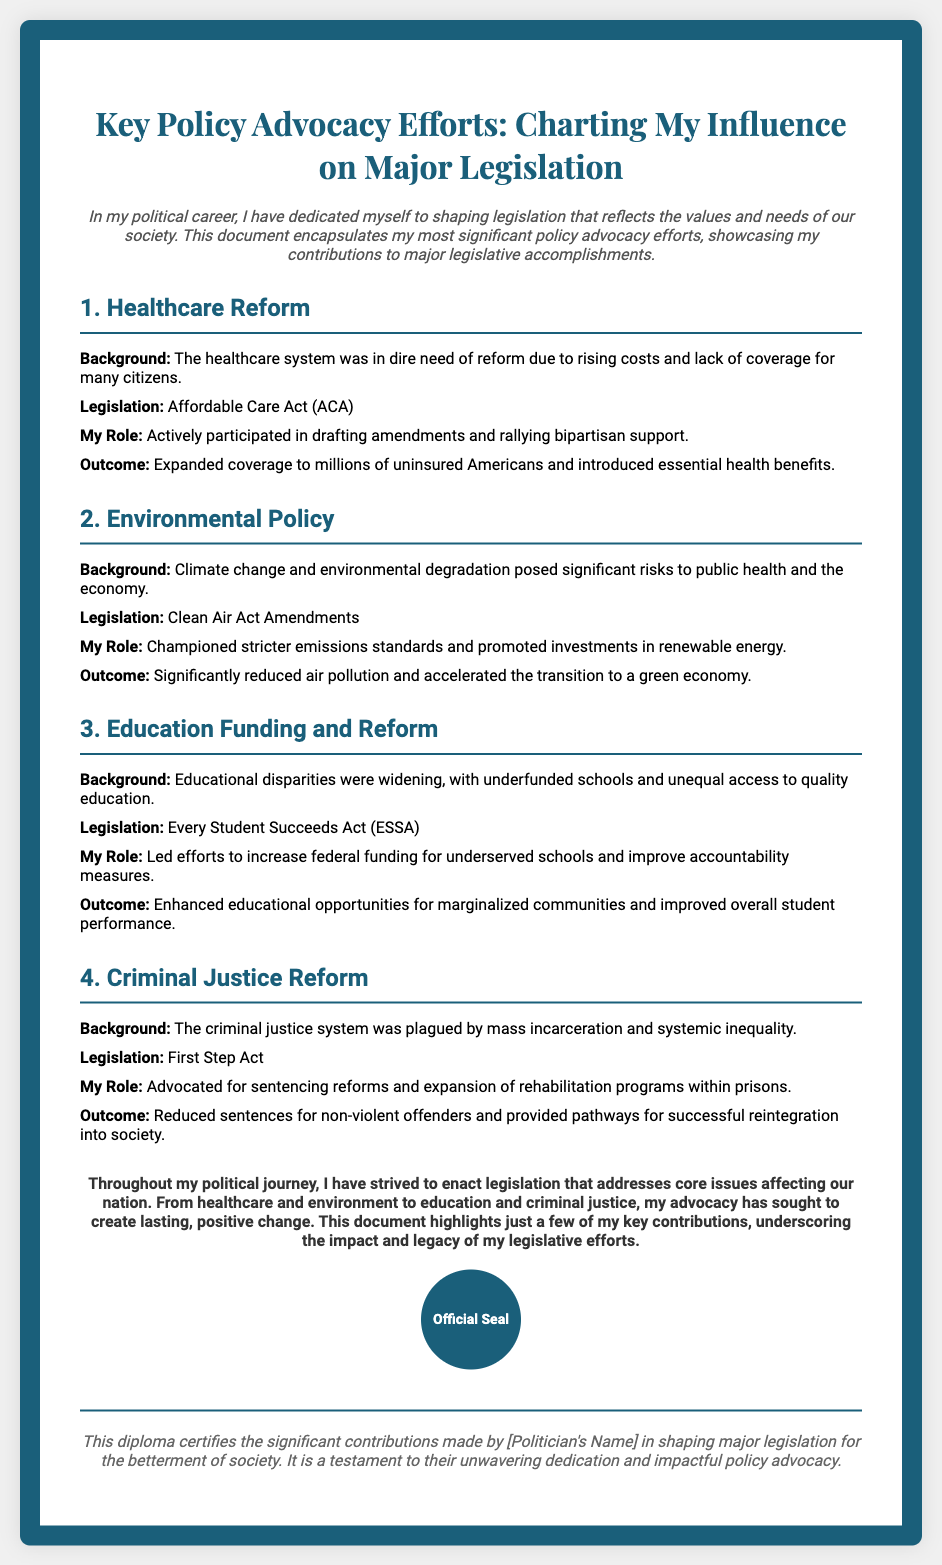What is the title of the diploma? The title of the diploma is prominently displayed at the top of the document.
Answer: Key Policy Advocacy Efforts: Charting My Influence on Major Legislation What is the first piece of legislation mentioned? The first legislative effort highlighted in the document is specifically named in the section about Healthcare Reform.
Answer: Affordable Care Act (ACA) What major issue did the Environmental Policy address? The document outlines a major concern that required legislative action within the Environmental Policy section.
Answer: Climate change Who led efforts to increase federal funding for education? The document identifies a specific person responsible for advocating education funding reforms.
Answer: [Politician's Name] What outcome resulted from the First Step Act? The outcome is mentioned as part of the description related to Criminal Justice Reform in the corresponding section of the document.
Answer: Reduced sentences for non-violent offenders What does the official seal represent? The seal serves a specific purpose in the context of this diploma document.
Answer: Official certification of contributions How many major policy advocacy efforts are highlighted? The document presents multiple sections detailing different legislative efforts, which can be counted.
Answer: Four What is the background issue for Healthcare Reform? The background issue leading to the need for healthcare reform is explained in the respective section.
Answer: Rising costs and lack of coverage What color is used for the diploma's border? The document describes a specific color that defines the aesthetic framing of the diploma.
Answer: Dark blue 